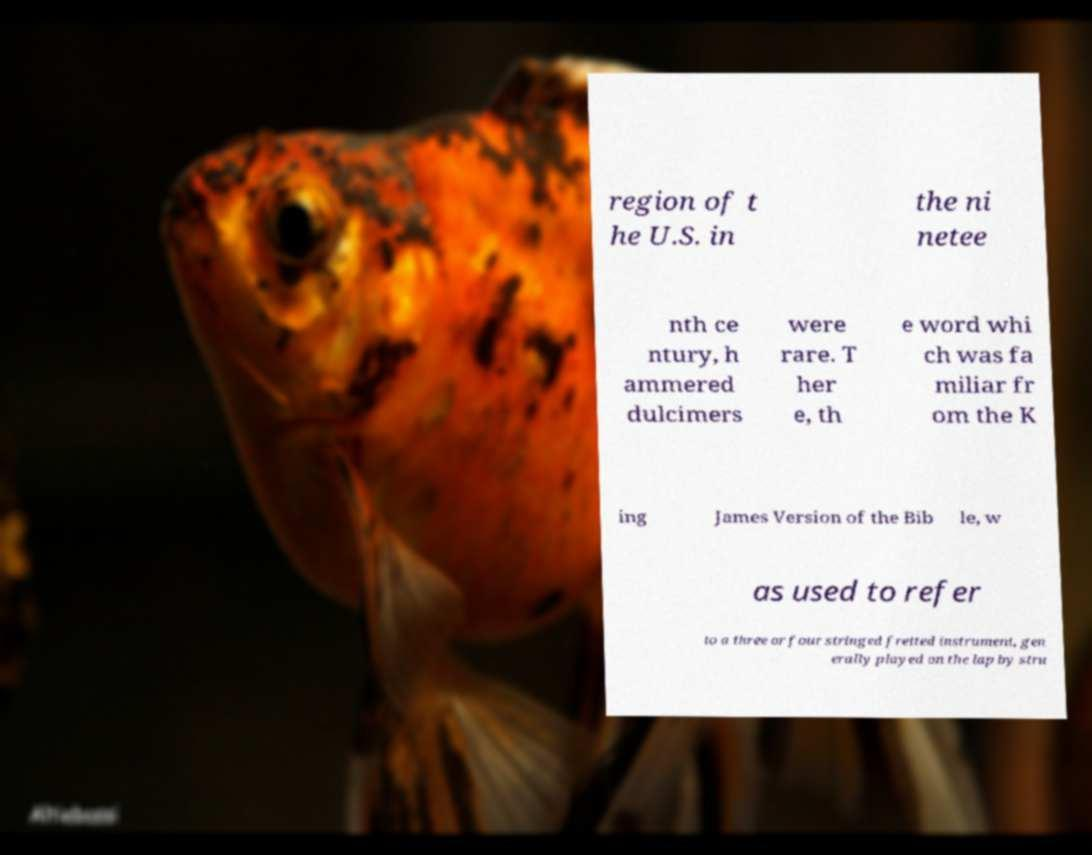What messages or text are displayed in this image? I need them in a readable, typed format. region of t he U.S. in the ni netee nth ce ntury, h ammered dulcimers were rare. T her e, th e word whi ch was fa miliar fr om the K ing James Version of the Bib le, w as used to refer to a three or four stringed fretted instrument, gen erally played on the lap by stru 